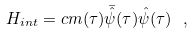Convert formula to latex. <formula><loc_0><loc_0><loc_500><loc_500>H _ { i n t } = c m ( \tau ) \bar { \hat { \psi } } ( \tau ) \hat { \psi } ( \tau ) \ ,</formula> 